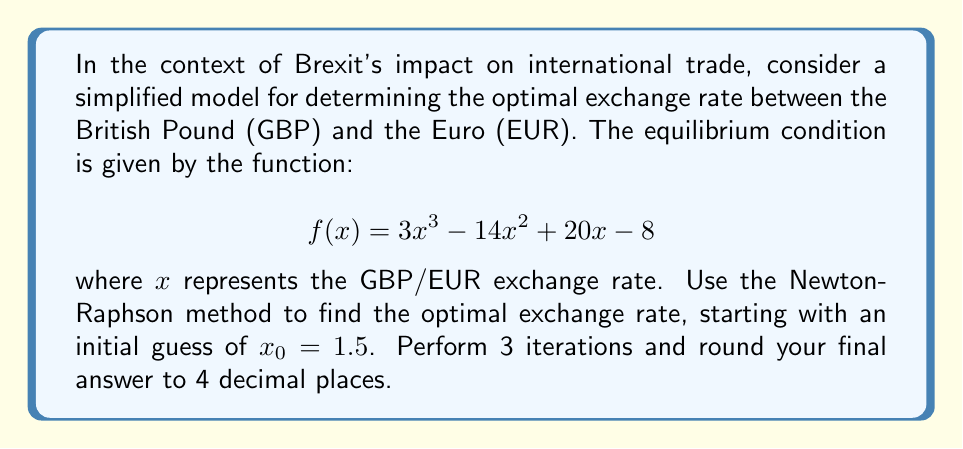Solve this math problem. To solve this problem using the Newton-Raphson method, we follow these steps:

1. The Newton-Raphson formula is:
   $$x_{n+1} = x_n - \frac{f(x_n)}{f'(x_n)}$$

2. We need to find $f'(x)$:
   $$f'(x) = 9x^2 - 28x + 20$$

3. Now we perform the iterations:

   Iteration 1:
   $$f(1.5) = 3(1.5)^3 - 14(1.5)^2 + 20(1.5) - 8 = -0.125$$
   $$f'(1.5) = 9(1.5)^2 - 28(1.5) + 20 = 2.75$$
   $$x_1 = 1.5 - \frac{-0.125}{2.75} = 1.5455$$

   Iteration 2:
   $$f(1.5455) = 3(1.5455)^3 - 14(1.5455)^2 + 20(1.5455) - 8 = 0.0031$$
   $$f'(1.5455) = 9(1.5455)^2 - 28(1.5455) + 20 = 2.9077$$
   $$x_2 = 1.5455 - \frac{0.0031}{2.9077} = 1.5444$$

   Iteration 3:
   $$f(1.5444) = 3(1.5444)^3 - 14(1.5444)^2 + 20(1.5444) - 8 = 0.0000$$
   $$f'(1.5444) = 9(1.5444)^2 - 28(1.5444) + 20 = 2.9033$$
   $$x_3 = 1.5444 - \frac{0.0000}{2.9033} = 1.5444$$

4. Rounding to 4 decimal places, our final answer is 1.5444.
Answer: 1.5444 